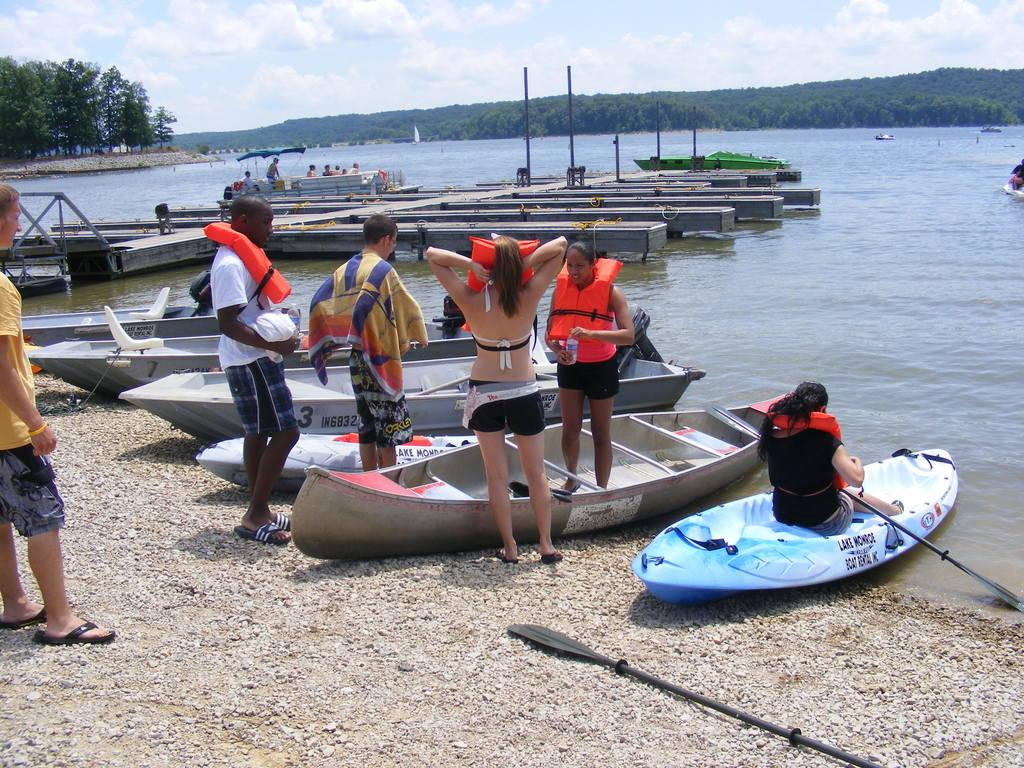What type of boats are on the left side of the image? There are skiffs on the left side of the image. What body of water is visible in the image? There is a sea on the right side of the image. What type of vegetation can be seen in the image? There are trees in the image. What geographical feature is covered with trees in the image? There is a mountain covered with trees in the image. What is the condition of the sky in the image? The sky is clear in the image. What type of pancake is being served on the mountain in the image? There is no pancake present in the image; it features skiffs, a sea, trees, and a mountain covered with trees. How many pins are visible on the trees in the image? There are no pins visible on the trees in the image. 